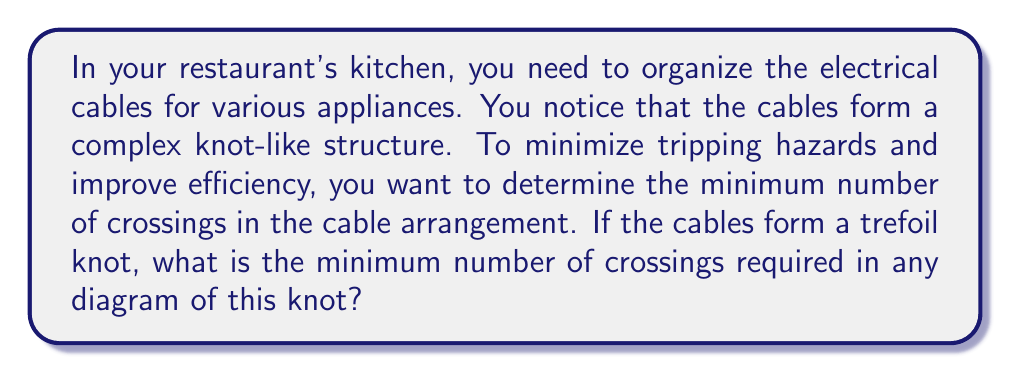Solve this math problem. To solve this problem, we need to understand some key concepts in knot theory:

1. The trefoil knot is one of the simplest non-trivial knots.

2. The crossing number of a knot is the minimum number of crossings required in any diagram of the knot.

3. For the trefoil knot, we can prove that the minimum number of crossings is 3:

   Step 1: Observe that the trefoil knot can be drawn with 3 crossings.
   
   [asy]
   import geometry;

   pair A = (0,0), B = (1,1), C = (-1,1);
   draw(A--B--C--cycle);
   draw(A--(0.33,0.67), dashed);
   draw((0.67,0.33)--B, dashed);
   draw((-0.33,0.67)--(0.33,0.67), dashed);
   [/asy]

   Step 2: Prove that it's impossible to draw with fewer than 3 crossings:
   - A knot with 0 or 1 crossing is trivial (can be untangled without cutting).
   - A knot with 2 crossings can always be reduced to a trivial knot.
   - Therefore, the minimum number of crossings for a non-trivial knot is 3.

   Step 3: The trefoil knot is non-trivial, so it must have at least 3 crossings.

4. Since we can draw the trefoil with 3 crossings, and it's impossible to draw with fewer, 3 is the minimum number of crossings.

In the context of cable management, this means that if your cables form a trefoil knot, you cannot arrange them with fewer than 3 crossings without untangling the knot completely.
Answer: 3 